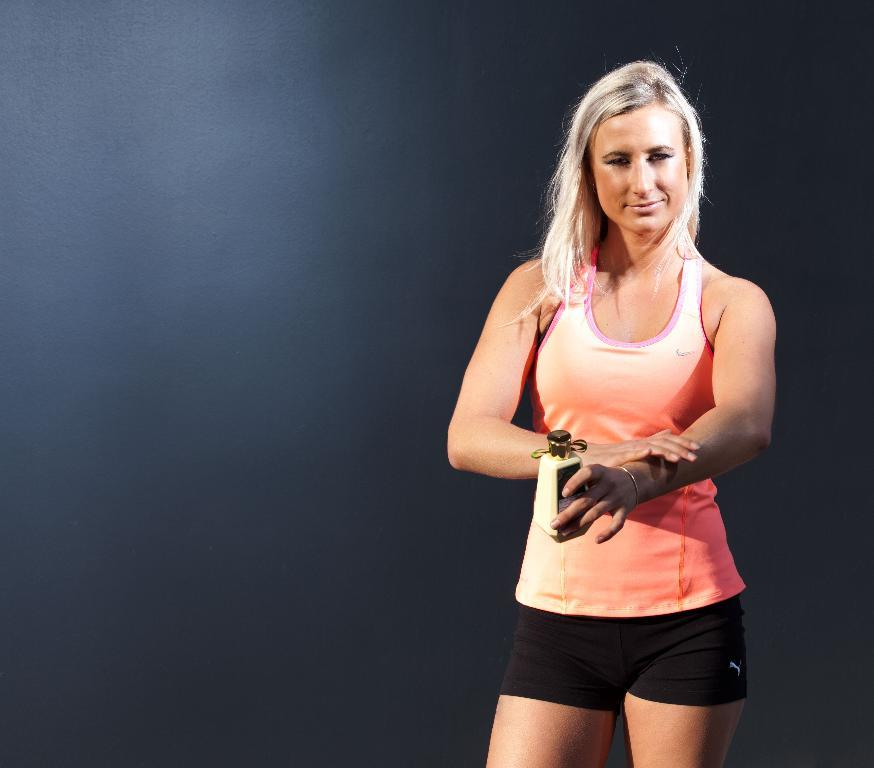Who is the main subject in the image? There is a woman in the image. What is the woman doing in the image? The woman is standing. What colors is the woman wearing in the image? The woman is wearing peach and black colors. What is the woman holding in the image? The woman is holding something. What can be seen in the background of the image? The background of the image is black. How many babies is the woman holding in the image? There are no babies present in the image; the woman is holding something else. What type of home is visible in the background of the image? There is no home visible in the background of the image; the background is black. 